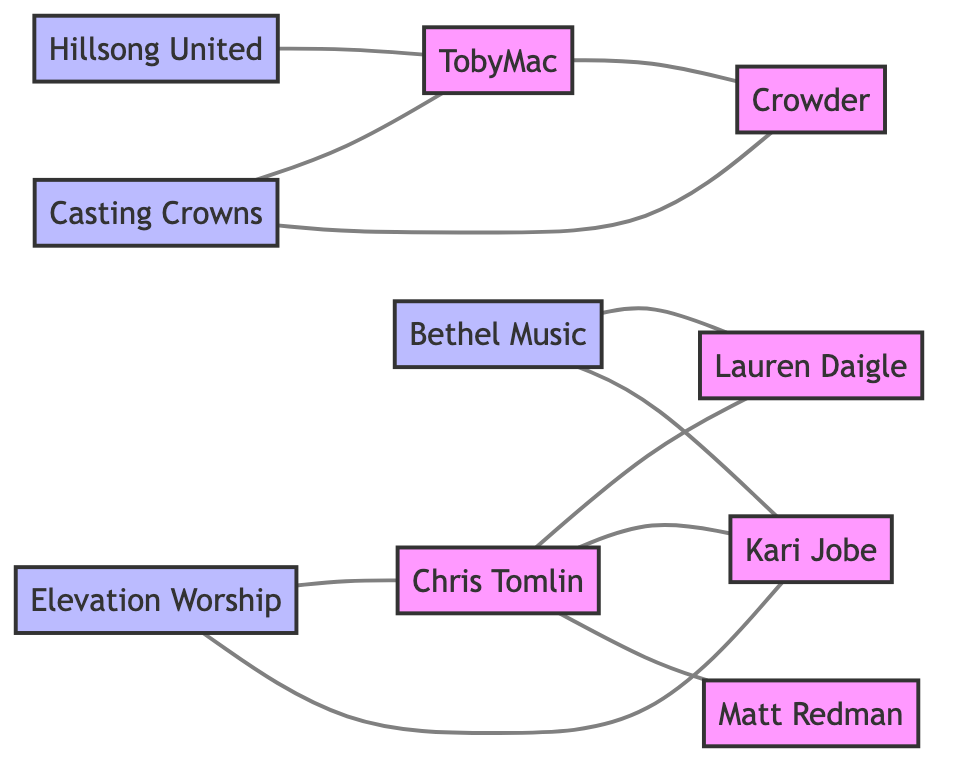What is the total number of artists in the diagram? The diagram contains the following artists: Chris Tomlin, Lauren Daigle, TobyMac, Kari Jobe, Crowder, Matt Redman. Counting these gives a total of 6 artists.
Answer: 6 Which band has a collaboration with Chris Tomlin? The link in the diagram indicates that Elevation Worship connects with Chris Tomlin through a collaboration.
Answer: Elevation Worship How many times does Kari Jobe appear in the diagram? By reviewing the connections, Kari Jobe appears three times: twice with Bethel Music and once with both Chris Tomlin and Elevation Worship.
Answer: 4 What type of relationship exists between Casting Crowns and TobyMac? The diagram defines the relationship between Casting Crowns and TobyMac as a tour collaboration based on the link connecting the two.
Answer: Tour Collaboration Which artist appears in a guest appearance alongside Bethel Music? The diagram illustrates that Lauren Daigle has a connection with Bethel Music through a guest appearance, identified by the corresponding link.
Answer: Lauren Daigle How many overall collaborations are there involving Chris Tomlin? The diagram shows Chris Tomlin is involved in collaborations with Lauren Daigle, Kari Jobe, Matt Redman, and Elevation Worship, making a total of 4 collaborations in which he participates.
Answer: 4 Which two artists are linked by a collaboration involving Crowder? In the diagram, Crowder collaborates with TobyMac, according to the established connection indicating that they worked together.
Answer: TobyMac What is the total number of connections in this graph? The diagram shows 10 links between the artists and bands, representing various forms of collaborations and appearances.
Answer: 10 